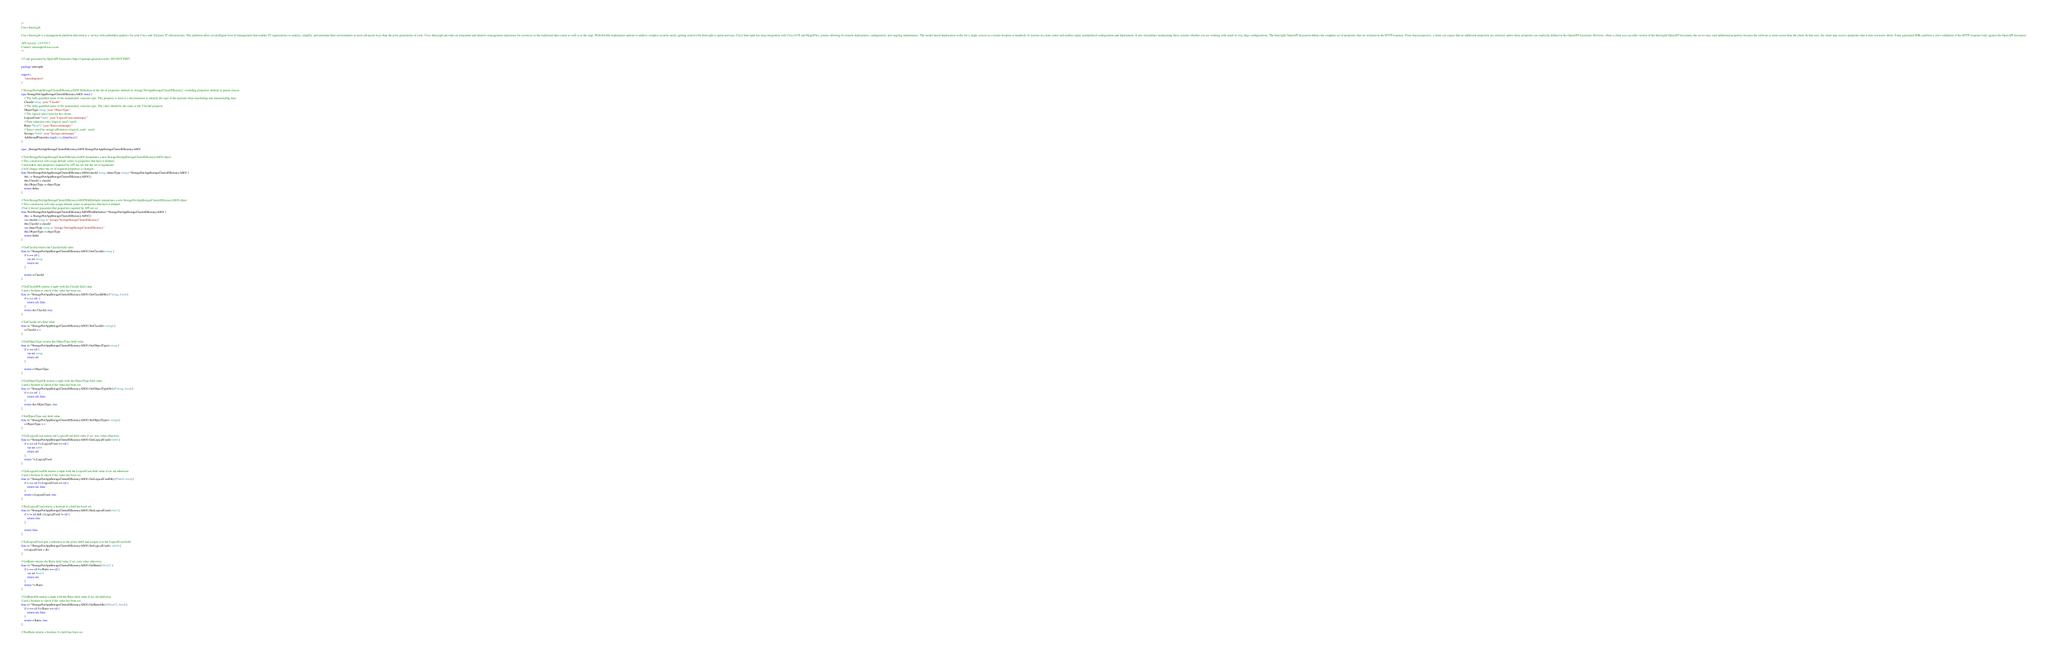<code> <loc_0><loc_0><loc_500><loc_500><_Go_>/*
Cisco Intersight

Cisco Intersight is a management platform delivered as a service with embedded analytics for your Cisco and 3rd party IT infrastructure. This platform offers an intelligent level of management that enables IT organizations to analyze, simplify, and automate their environments in more advanced ways than the prior generations of tools. Cisco Intersight provides an integrated and intuitive management experience for resources in the traditional data center as well as at the edge. With flexible deployment options to address complex security needs, getting started with Intersight is quick and easy. Cisco Intersight has deep integration with Cisco UCS and HyperFlex systems allowing for remote deployment, configuration, and ongoing maintenance. The model-based deployment works for a single system in a remote location or hundreds of systems in a data center and enables rapid, standardized configuration and deployment. It also streamlines maintaining those systems whether you are working with small or very large configurations. The Intersight OpenAPI document defines the complete set of properties that are returned in the HTTP response. From that perspective, a client can expect that no additional properties are returned, unless these properties are explicitly defined in the OpenAPI document. However, when a client uses an older version of the Intersight OpenAPI document, the server may send additional properties because the software is more recent than the client. In that case, the client may receive properties that it does not know about. Some generated SDKs perform a strict validation of the HTTP response body against the OpenAPI document.

API version: 1.0.9-5517
Contact: intersight@cisco.com
*/

// Code generated by OpenAPI Generator (https://openapi-generator.tech); DO NOT EDIT.

package intersight

import (
	"encoding/json"
)

// StorageNetAppStorageClusterEfficiencyAllOf Definition of the list of properties defined in 'storage.NetAppStorageClusterEfficiency', excluding properties defined in parent classes.
type StorageNetAppStorageClusterEfficiencyAllOf struct {
	// The fully-qualified name of the instantiated, concrete type. This property is used as a discriminator to identify the type of the payload when marshaling and unmarshaling data.
	ClassId string `json:"ClassId"`
	// The fully-qualified name of the instantiated, concrete type. The value should be the same as the 'ClassId' property.
	ObjectType string `json:"ObjectType"`
	// The logical space used for the cluster.
	LogicalUsed *int64 `json:"LogicalUsed,omitempty"`
	// Data reduction ratio (logical_used / used).
	Ratio *float32 `json:"Ratio,omitempty"`
	// Space saved by storage efficiencies (logical_used - used).
	Savings *int64 `json:"Savings,omitempty"`
	AdditionalProperties map[string]interface{}
}

type _StorageNetAppStorageClusterEfficiencyAllOf StorageNetAppStorageClusterEfficiencyAllOf

// NewStorageNetAppStorageClusterEfficiencyAllOf instantiates a new StorageNetAppStorageClusterEfficiencyAllOf object
// This constructor will assign default values to properties that have it defined,
// and makes sure properties required by API are set, but the set of arguments
// will change when the set of required properties is changed
func NewStorageNetAppStorageClusterEfficiencyAllOf(classId string, objectType string) *StorageNetAppStorageClusterEfficiencyAllOf {
	this := StorageNetAppStorageClusterEfficiencyAllOf{}
	this.ClassId = classId
	this.ObjectType = objectType
	return &this
}

// NewStorageNetAppStorageClusterEfficiencyAllOfWithDefaults instantiates a new StorageNetAppStorageClusterEfficiencyAllOf object
// This constructor will only assign default values to properties that have it defined,
// but it doesn't guarantee that properties required by API are set
func NewStorageNetAppStorageClusterEfficiencyAllOfWithDefaults() *StorageNetAppStorageClusterEfficiencyAllOf {
	this := StorageNetAppStorageClusterEfficiencyAllOf{}
	var classId string = "storage.NetAppStorageClusterEfficiency"
	this.ClassId = classId
	var objectType string = "storage.NetAppStorageClusterEfficiency"
	this.ObjectType = objectType
	return &this
}

// GetClassId returns the ClassId field value
func (o *StorageNetAppStorageClusterEfficiencyAllOf) GetClassId() string {
	if o == nil {
		var ret string
		return ret
	}

	return o.ClassId
}

// GetClassIdOk returns a tuple with the ClassId field value
// and a boolean to check if the value has been set.
func (o *StorageNetAppStorageClusterEfficiencyAllOf) GetClassIdOk() (*string, bool) {
	if o == nil  {
		return nil, false
	}
	return &o.ClassId, true
}

// SetClassId sets field value
func (o *StorageNetAppStorageClusterEfficiencyAllOf) SetClassId(v string) {
	o.ClassId = v
}

// GetObjectType returns the ObjectType field value
func (o *StorageNetAppStorageClusterEfficiencyAllOf) GetObjectType() string {
	if o == nil {
		var ret string
		return ret
	}

	return o.ObjectType
}

// GetObjectTypeOk returns a tuple with the ObjectType field value
// and a boolean to check if the value has been set.
func (o *StorageNetAppStorageClusterEfficiencyAllOf) GetObjectTypeOk() (*string, bool) {
	if o == nil  {
		return nil, false
	}
	return &o.ObjectType, true
}

// SetObjectType sets field value
func (o *StorageNetAppStorageClusterEfficiencyAllOf) SetObjectType(v string) {
	o.ObjectType = v
}

// GetLogicalUsed returns the LogicalUsed field value if set, zero value otherwise.
func (o *StorageNetAppStorageClusterEfficiencyAllOf) GetLogicalUsed() int64 {
	if o == nil || o.LogicalUsed == nil {
		var ret int64
		return ret
	}
	return *o.LogicalUsed
}

// GetLogicalUsedOk returns a tuple with the LogicalUsed field value if set, nil otherwise
// and a boolean to check if the value has been set.
func (o *StorageNetAppStorageClusterEfficiencyAllOf) GetLogicalUsedOk() (*int64, bool) {
	if o == nil || o.LogicalUsed == nil {
		return nil, false
	}
	return o.LogicalUsed, true
}

// HasLogicalUsed returns a boolean if a field has been set.
func (o *StorageNetAppStorageClusterEfficiencyAllOf) HasLogicalUsed() bool {
	if o != nil && o.LogicalUsed != nil {
		return true
	}

	return false
}

// SetLogicalUsed gets a reference to the given int64 and assigns it to the LogicalUsed field.
func (o *StorageNetAppStorageClusterEfficiencyAllOf) SetLogicalUsed(v int64) {
	o.LogicalUsed = &v
}

// GetRatio returns the Ratio field value if set, zero value otherwise.
func (o *StorageNetAppStorageClusterEfficiencyAllOf) GetRatio() float32 {
	if o == nil || o.Ratio == nil {
		var ret float32
		return ret
	}
	return *o.Ratio
}

// GetRatioOk returns a tuple with the Ratio field value if set, nil otherwise
// and a boolean to check if the value has been set.
func (o *StorageNetAppStorageClusterEfficiencyAllOf) GetRatioOk() (*float32, bool) {
	if o == nil || o.Ratio == nil {
		return nil, false
	}
	return o.Ratio, true
}

// HasRatio returns a boolean if a field has been set.</code> 